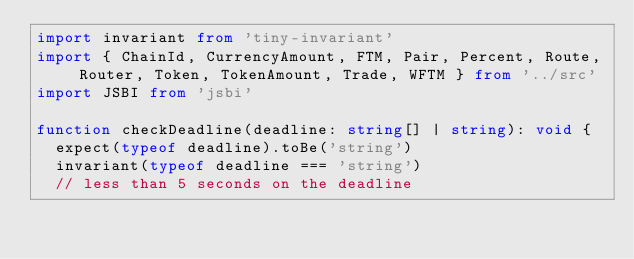Convert code to text. <code><loc_0><loc_0><loc_500><loc_500><_TypeScript_>import invariant from 'tiny-invariant'
import { ChainId, CurrencyAmount, FTM, Pair, Percent, Route, Router, Token, TokenAmount, Trade, WFTM } from '../src'
import JSBI from 'jsbi'

function checkDeadline(deadline: string[] | string): void {
  expect(typeof deadline).toBe('string')
  invariant(typeof deadline === 'string')
  // less than 5 seconds on the deadline</code> 